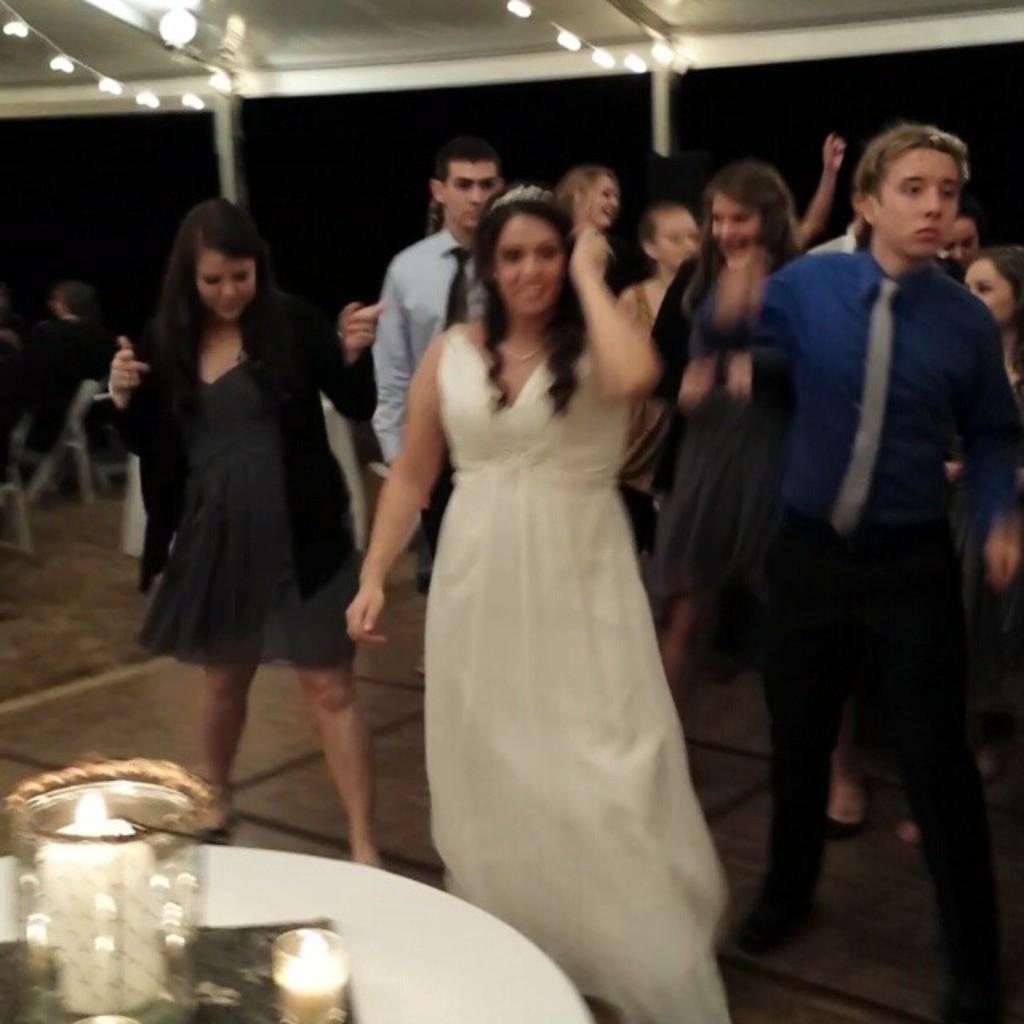Please provide a concise description of this image. It is a blur image, there are a group of people dancing and in front of them there is a table and on the table there are two candles. 